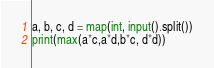<code> <loc_0><loc_0><loc_500><loc_500><_Python_>a, b, c, d = map(int, input().split())
print(max(a*c,a*d,b*c, d*d))</code> 